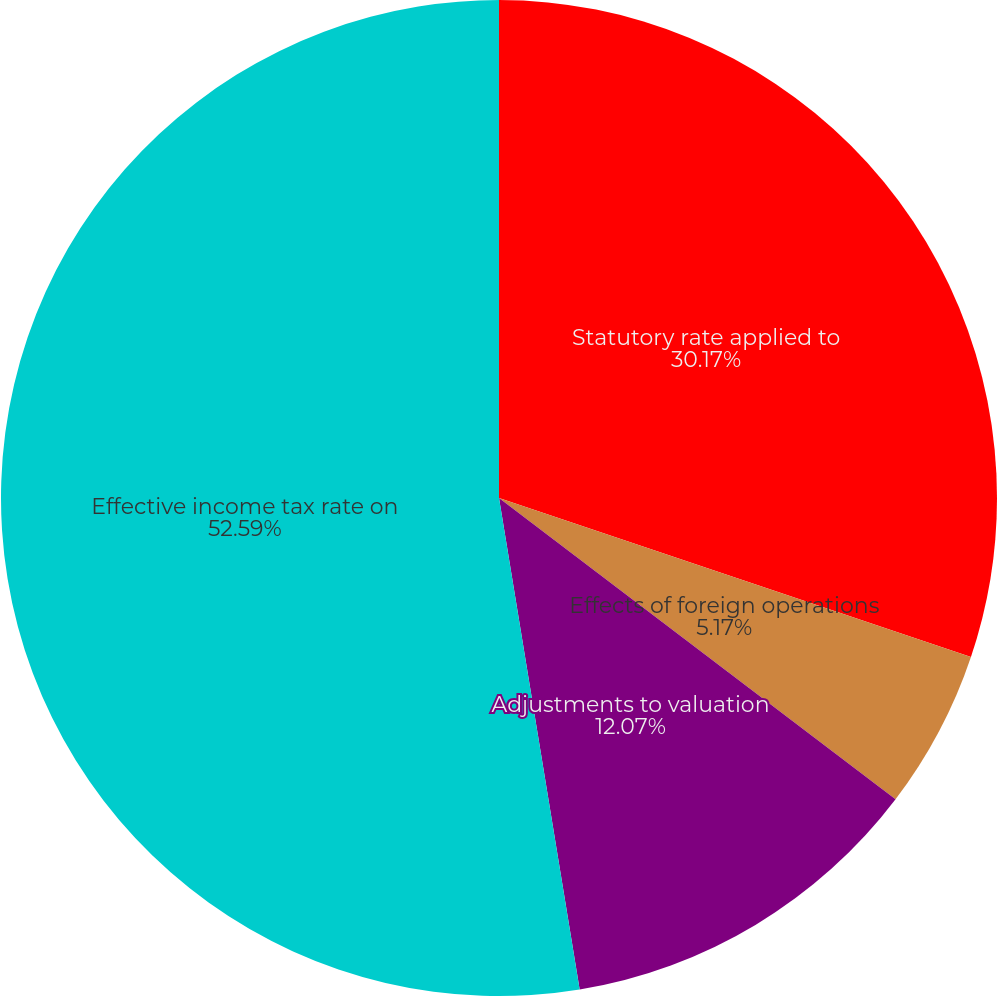Convert chart. <chart><loc_0><loc_0><loc_500><loc_500><pie_chart><fcel>Statutory rate applied to<fcel>Effects of foreign operations<fcel>Adjustments to valuation<fcel>Effective income tax rate on<nl><fcel>30.17%<fcel>5.17%<fcel>12.07%<fcel>52.59%<nl></chart> 